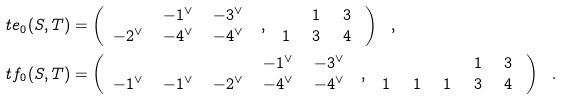Convert formula to latex. <formula><loc_0><loc_0><loc_500><loc_500>\ t e _ { 0 } ( S , T ) & = \left ( \begin{array} { c c c } & - 1 ^ { \vee } \, & - 3 ^ { \vee } \, \\ - 2 ^ { \vee } \, & - 4 ^ { \vee } \, & - 4 ^ { \vee } \, \end{array} \ , \ \begin{array} { c c c } & 1 \ & 3 \ \\ 1 \ & 3 \ & 4 \ \end{array} \right ) \ \ , \\ \ t f _ { 0 } ( S , T ) & = \left ( \begin{array} { c c c c c } & & & - 1 ^ { \vee } \, & - 3 ^ { \vee } \, \\ - 1 ^ { \vee } \, & - 1 ^ { \vee } \, & - 2 ^ { \vee } \, & - 4 ^ { \vee } \, & - 4 ^ { \vee } \, \end{array} \ , \ \begin{array} { c c c c c } & & & 1 \ & 3 \ \\ 1 \ & 1 \ & 1 \ & 3 \ & 4 \ \end{array} \right ) \ \ .</formula> 